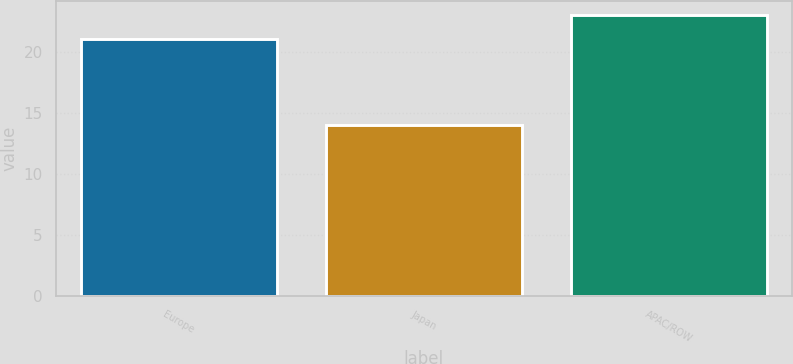Convert chart to OTSL. <chart><loc_0><loc_0><loc_500><loc_500><bar_chart><fcel>Europe<fcel>Japan<fcel>APAC/ROW<nl><fcel>21<fcel>14<fcel>23<nl></chart> 